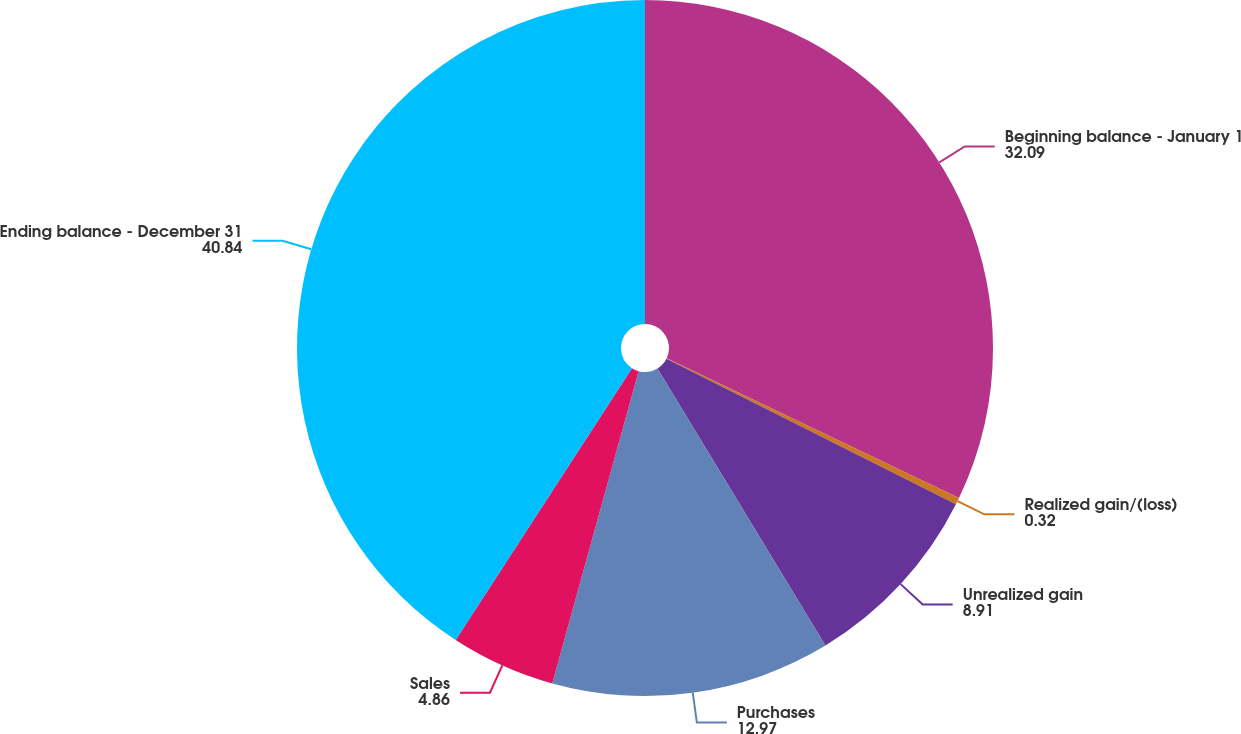Convert chart to OTSL. <chart><loc_0><loc_0><loc_500><loc_500><pie_chart><fcel>Beginning balance - January 1<fcel>Realized gain/(loss)<fcel>Unrealized gain<fcel>Purchases<fcel>Sales<fcel>Ending balance - December 31<nl><fcel>32.09%<fcel>0.32%<fcel>8.91%<fcel>12.97%<fcel>4.86%<fcel>40.84%<nl></chart> 